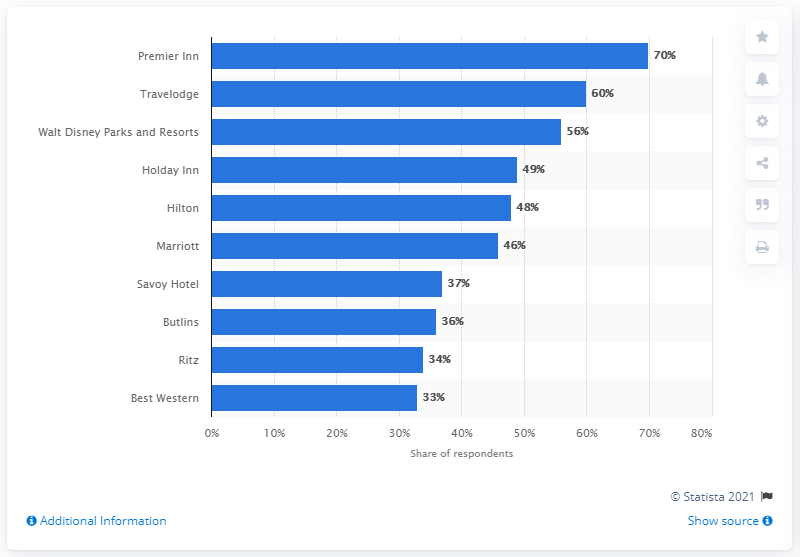Mention a couple of crucial points in this snapshot. Premier Inn was the most popular hotel brand in the UK, according to YouGov ratings. Travelodge was the second most popular hotel brand in the UK. 